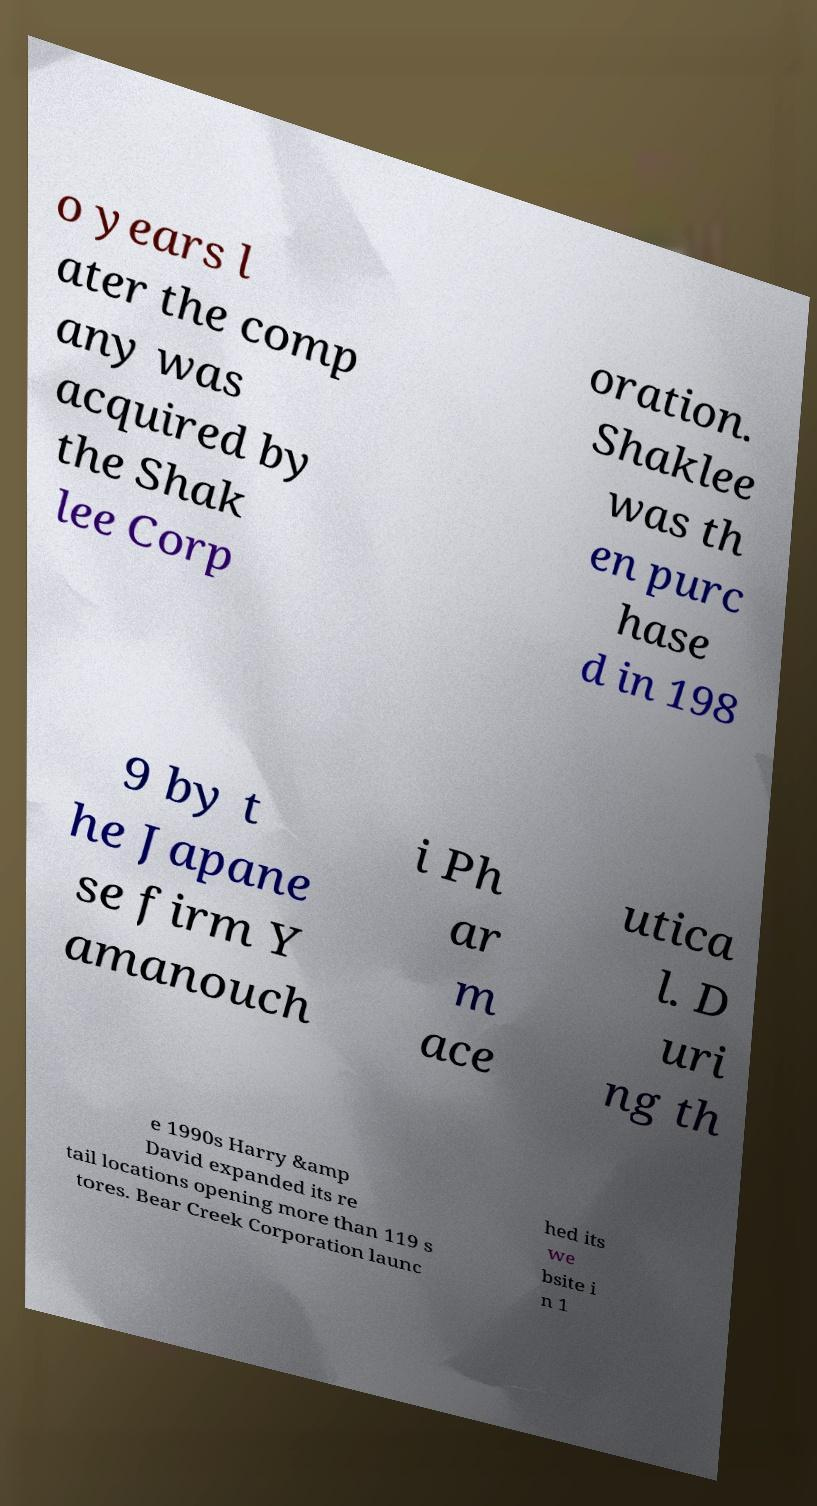What messages or text are displayed in this image? I need them in a readable, typed format. o years l ater the comp any was acquired by the Shak lee Corp oration. Shaklee was th en purc hase d in 198 9 by t he Japane se firm Y amanouch i Ph ar m ace utica l. D uri ng th e 1990s Harry &amp David expanded its re tail locations opening more than 119 s tores. Bear Creek Corporation launc hed its we bsite i n 1 